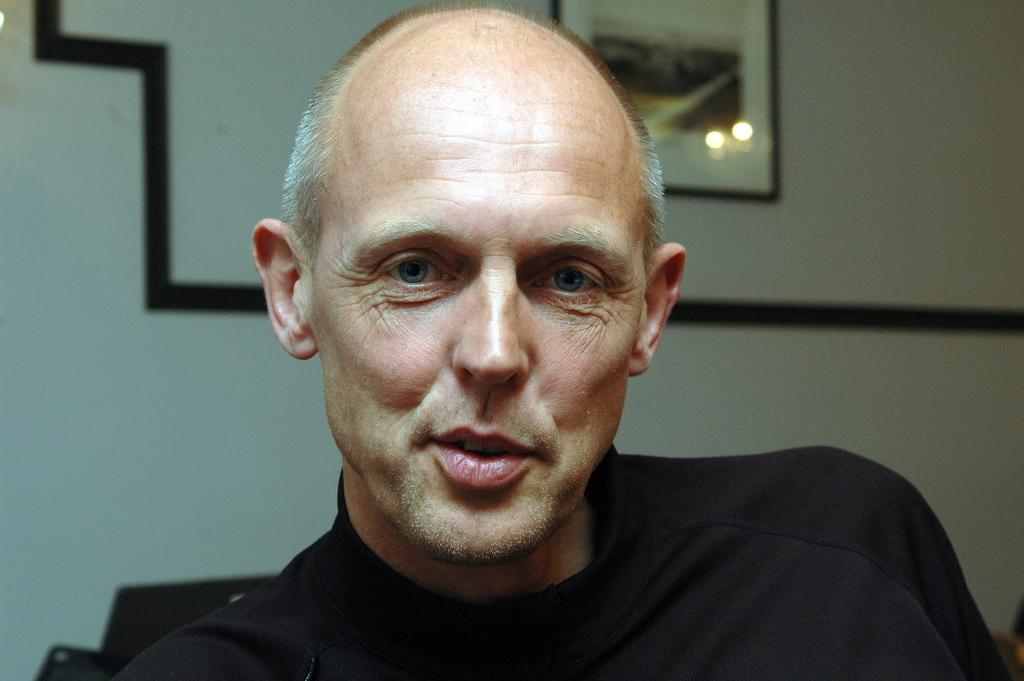What is present in the image? There is a man in the image. What is the man wearing? The man is wearing a black t-shirt. What can be seen on the wall in the image? There is a photo frame on the wall in the image. What type of cord is the man holding in the image? There is no cord present in the image. Are there any worms crawling on the man's black t-shirt in the image? There are no worms present in the image. What type of tomatoes can be seen growing on the wall in the image? There are no tomatoes present in the image. 